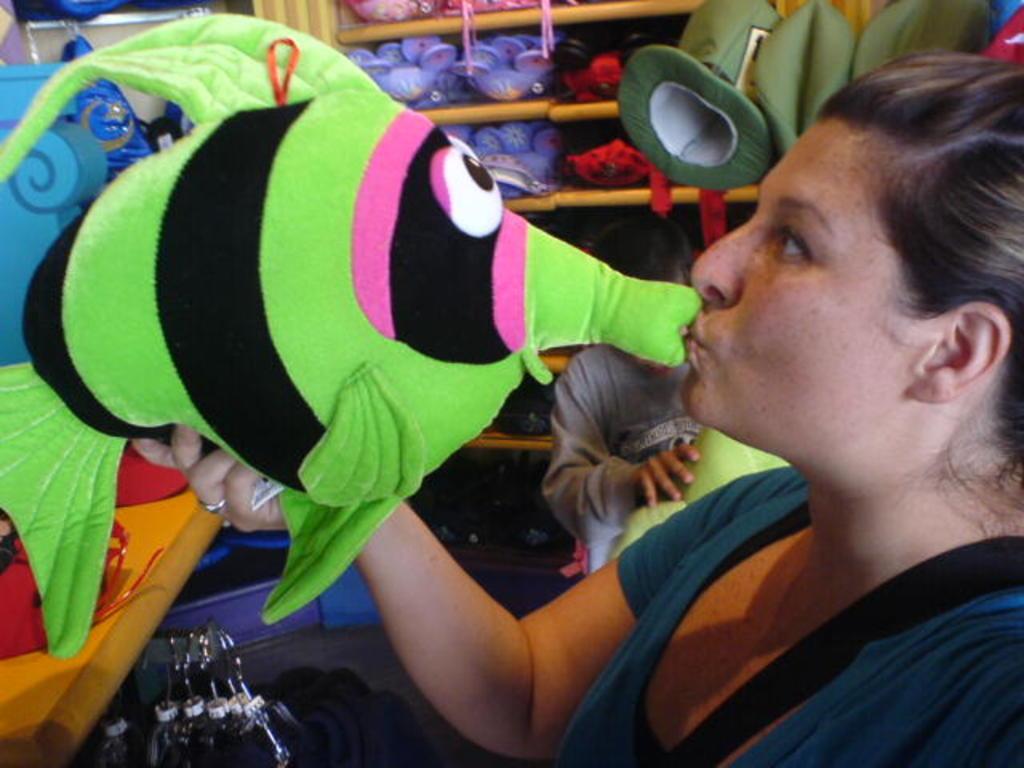Please provide a concise description of this image. In this image we can see two persons standing. One woman is holding green toy in her hand. In the background we can see group of toys placed in a rack. 